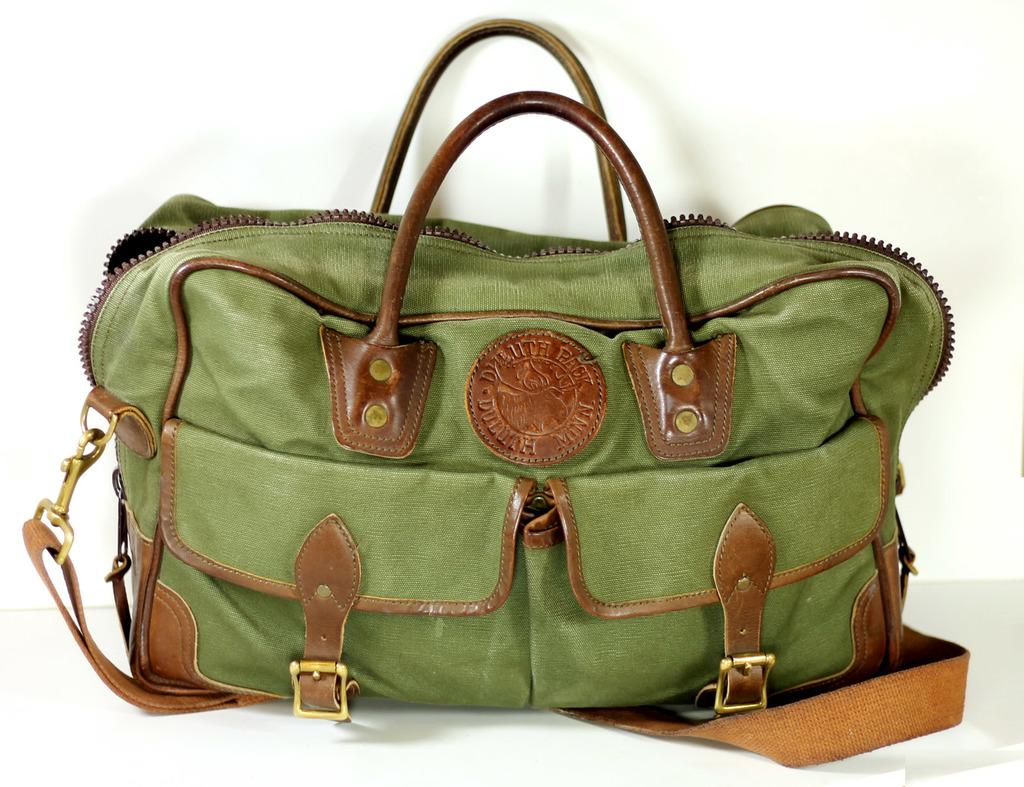What object can be seen in the image? There is a bag in the image. How does the yak interact with the bag in the image? There is no yak present in the image, so it cannot interact with the bag. 